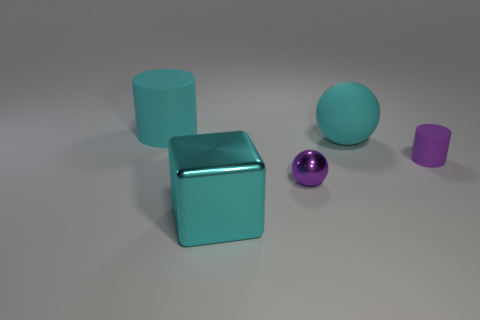What could be a potential use for the large turquoise cube in a real-world setting? The large turquoise cube could serve as a decorative piece in a modern living space, or if it's hollow, it might be used as storage. Its clean lines and simple geometry could complement minimalist or contemporary decor. Could it function as seating? Absolutely, if the cube is sturdy and appropriately sized, it could double as a unique and modern stool or side table in a living area. 